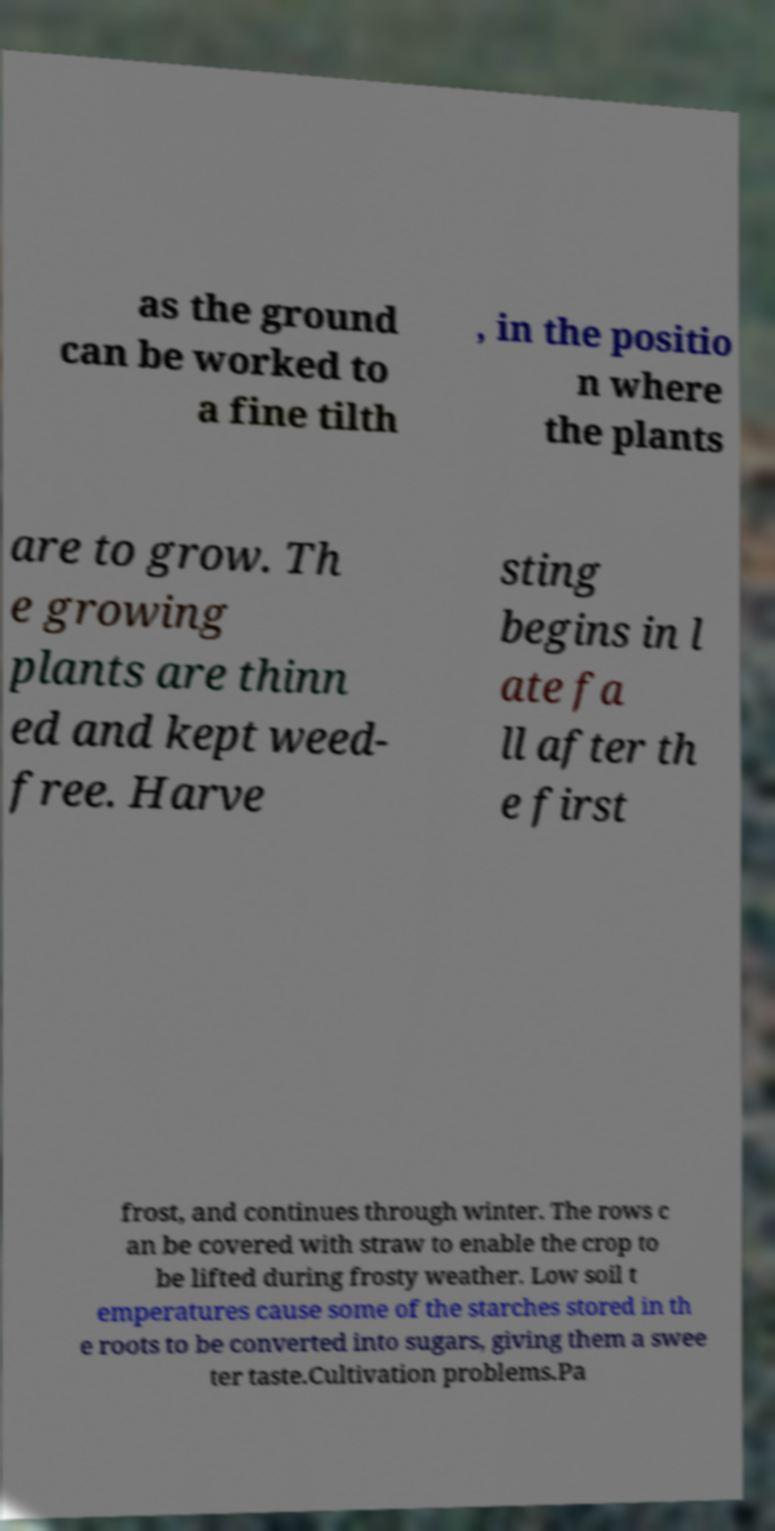For documentation purposes, I need the text within this image transcribed. Could you provide that? as the ground can be worked to a fine tilth , in the positio n where the plants are to grow. Th e growing plants are thinn ed and kept weed- free. Harve sting begins in l ate fa ll after th e first frost, and continues through winter. The rows c an be covered with straw to enable the crop to be lifted during frosty weather. Low soil t emperatures cause some of the starches stored in th e roots to be converted into sugars, giving them a swee ter taste.Cultivation problems.Pa 